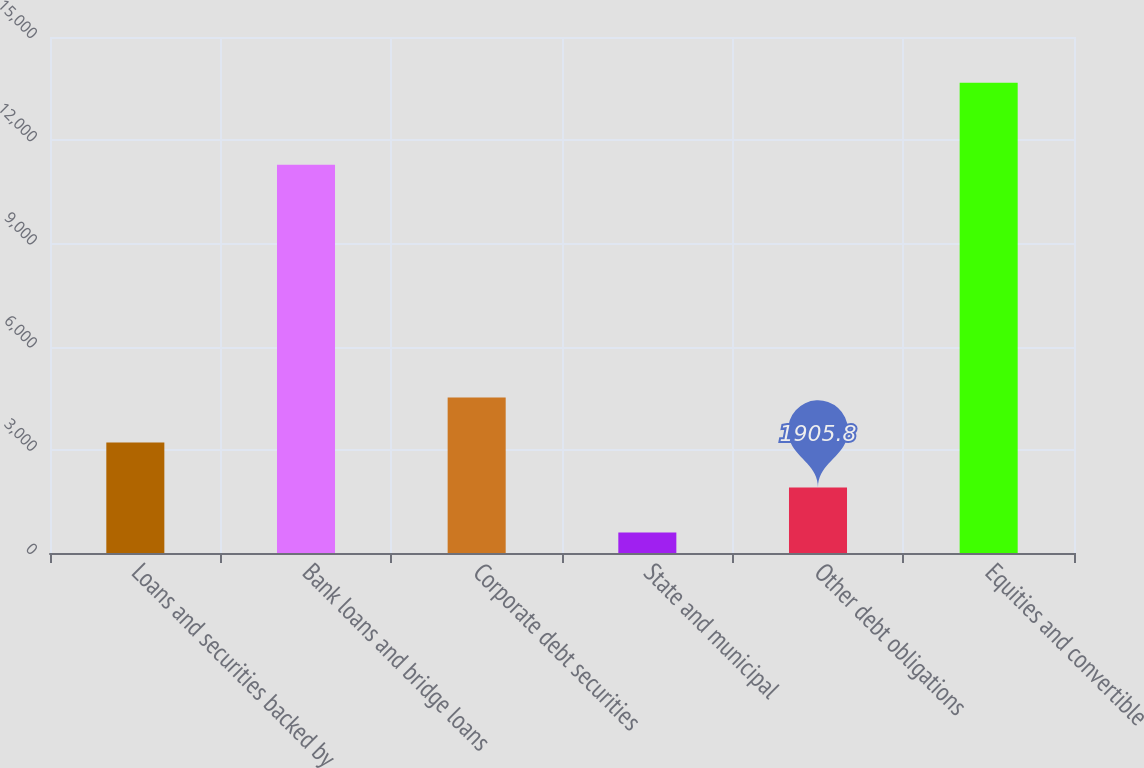<chart> <loc_0><loc_0><loc_500><loc_500><bar_chart><fcel>Loans and securities backed by<fcel>Bank loans and bridge loans<fcel>Corporate debt securities<fcel>State and municipal<fcel>Other debt obligations<fcel>Equities and convertible<nl><fcel>3212.6<fcel>11285<fcel>4519.4<fcel>599<fcel>1905.8<fcel>13667<nl></chart> 